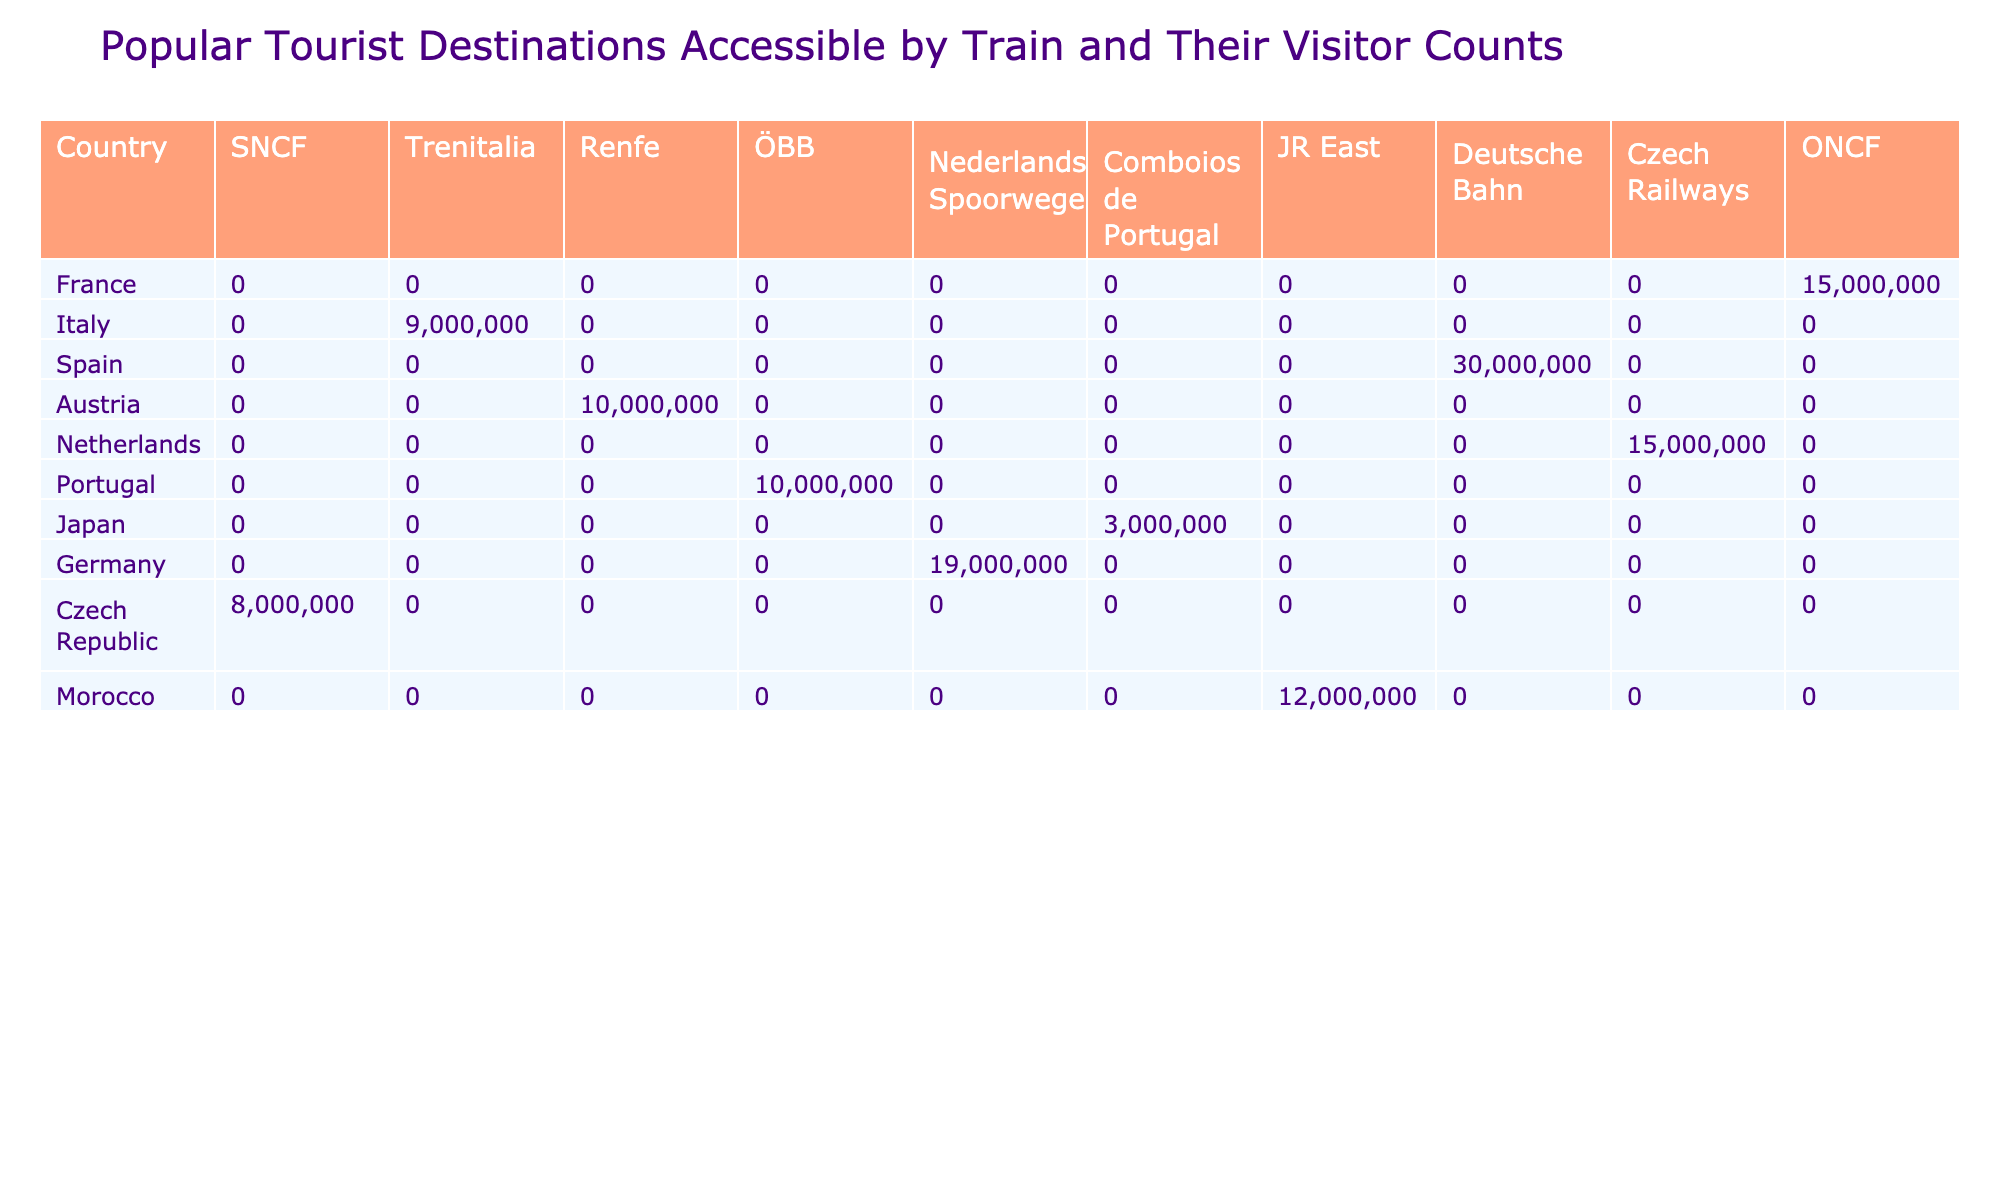What is the visitor count for Paris? The table shows that the visitor count for Paris in 2022 is listed under the column for France. Looking at the row corresponding to France, I can see that the visitor count is 30,000,000.
Answer: 30,000,000 Which country has the highest number of visitors? By comparing the visitor counts listed in the table, I can see that Paris (France) has the highest visitor count with 30,000,000, which is greater than any other destination's visitor count.
Answer: France What is the combined visitor count for destinations served by Trenitalia? To calculate the combined visitor count for Trenitalia (Italy), I only need to look for the visitor count for Rome, which is 15,000,000. Since it's the only destination served by Trenitalia in the table, the combined visitor count is simply 15,000,000.
Answer: 15,000,000 Are there more visitors to Barcelona than to Amsterdam? By examining the visitor counts, I see that Barcelona has 12,000,000 visitors, while Amsterdam has 19,000,000. Therefore, it is clear that there are fewer visitors to Barcelona than to Amsterdam.
Answer: No What is the average visitor count for countries that provide train services with more than 10 million visitors? I first identify the countries with visitor counts over 10 million: France (30,000,000), Italy (15,000,000), Spain (12,000,000), and the Netherlands (19,000,000). The sum of these counts is 30,000,000 + 15,000,000 + 12,000,000 + 19,000,000 = 76,000,000. There are 4 countries, so the average is 76,000,000 divided by 4, which equals 19,000,000.
Answer: 19,000,000 Is there a train service in Czech Republic? Czech Railways is listed under the train services in the table, indicating that there is indeed a train service available in the Czech Republic.
Answer: Yes Which train service appears the most frequently in the table? I review the table and count occurrences of each train service listed: SNCF appears once, Trenitalia once, Renfe once, ÖBB once, Nederlandse Spoorwegen once, Comboios de Portugal once, JR East once, Deutsche Bahn once, and Czech Railways once. Thus, every train service appears only once, meaning there is no single service that appears more frequently than the others.
Answer: None, all appear once What is the visitor count difference between Tokyo and Marrakech? The visitor count for Tokyo is 10,000,000, and for Marrakech, it is 3,000,000. To find the difference, I subtract the visitor count of Marrakech from that of Tokyo: 10,000,000 - 3,000,000 = 7,000,000.
Answer: 7,000,000 